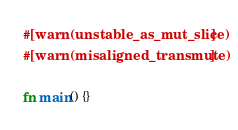Convert code to text. <code><loc_0><loc_0><loc_500><loc_500><_Rust_>#[warn(unstable_as_mut_slice)]
#[warn(misaligned_transmute)]

fn main() {}
</code> 